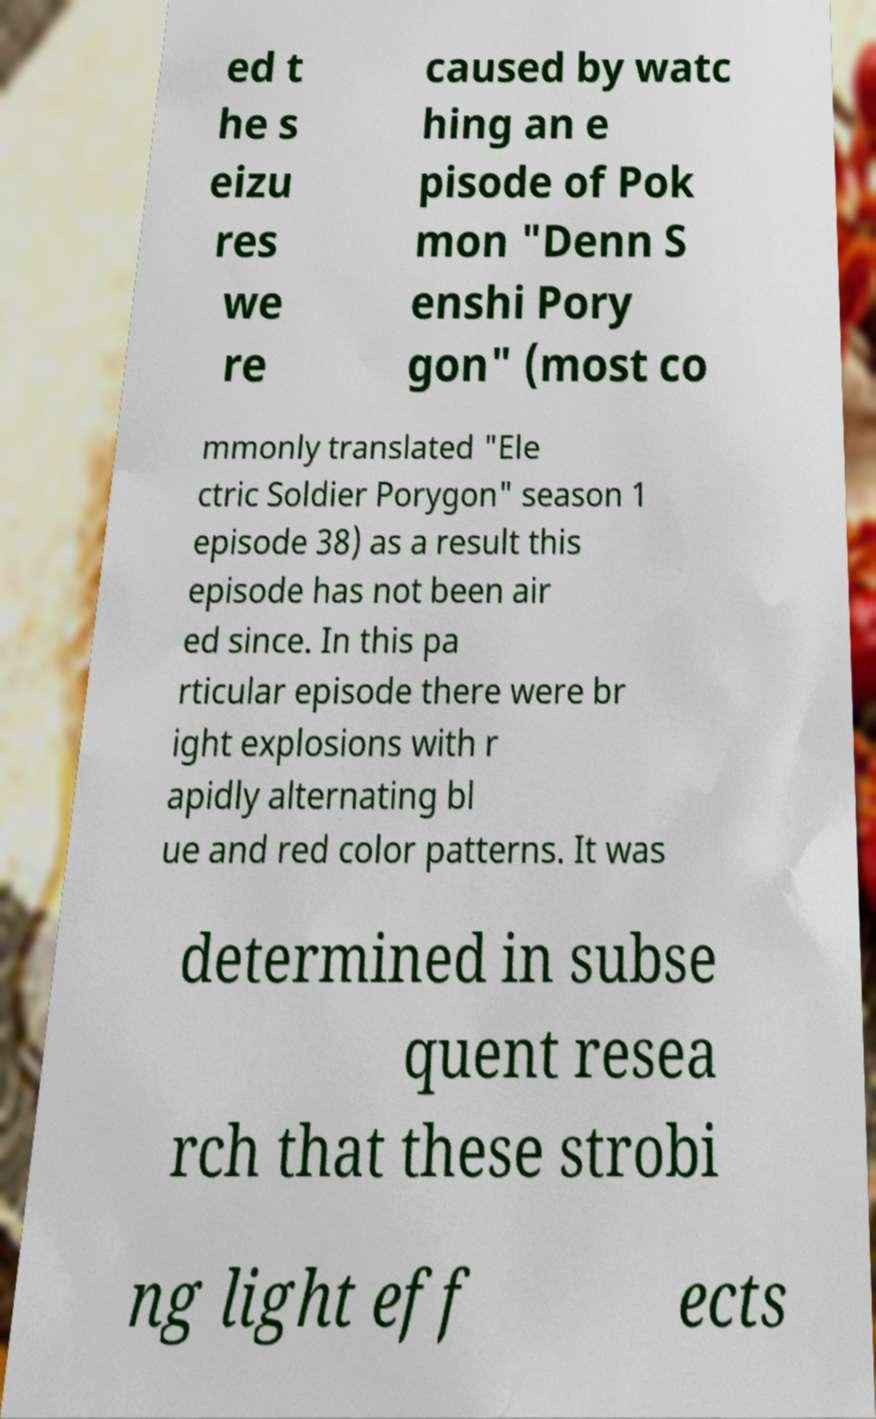What messages or text are displayed in this image? I need them in a readable, typed format. ed t he s eizu res we re caused by watc hing an e pisode of Pok mon "Denn S enshi Pory gon" (most co mmonly translated "Ele ctric Soldier Porygon" season 1 episode 38) as a result this episode has not been air ed since. In this pa rticular episode there were br ight explosions with r apidly alternating bl ue and red color patterns. It was determined in subse quent resea rch that these strobi ng light eff ects 